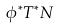Convert formula to latex. <formula><loc_0><loc_0><loc_500><loc_500>\phi ^ { * } T ^ { * } N</formula> 